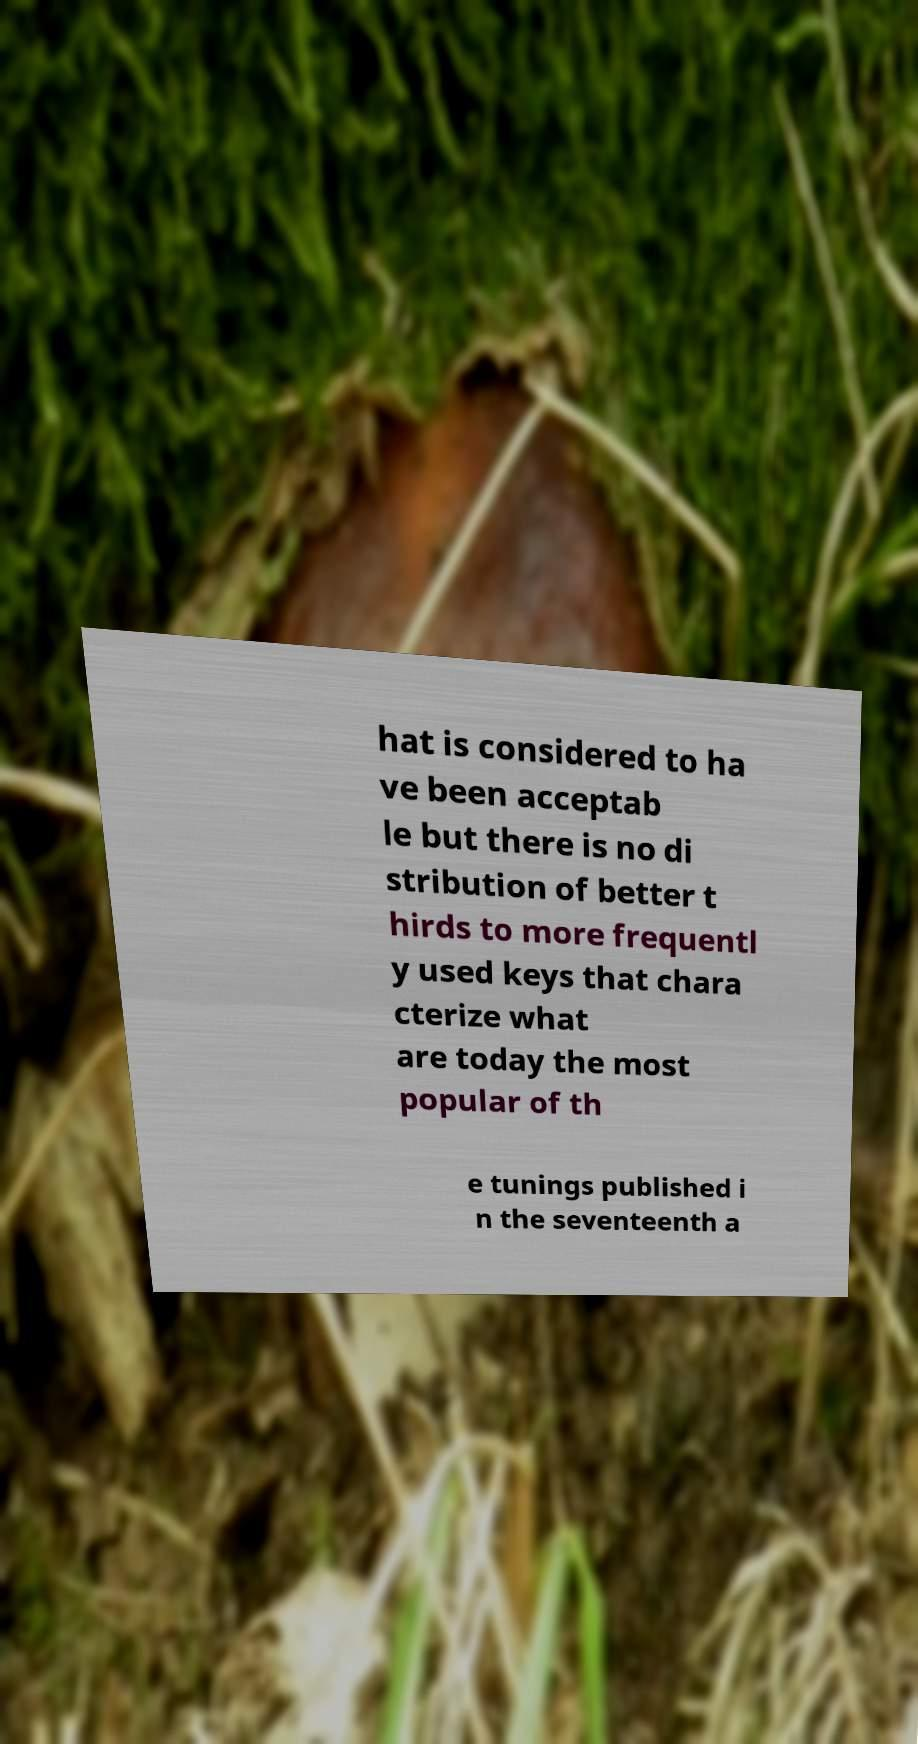There's text embedded in this image that I need extracted. Can you transcribe it verbatim? hat is considered to ha ve been acceptab le but there is no di stribution of better t hirds to more frequentl y used keys that chara cterize what are today the most popular of th e tunings published i n the seventeenth a 